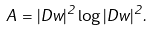Convert formula to latex. <formula><loc_0><loc_0><loc_500><loc_500>A = | D w | ^ { 2 } \log | D w | ^ { 2 } .</formula> 